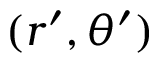<formula> <loc_0><loc_0><loc_500><loc_500>( r ^ { \prime } , \theta ^ { \prime } )</formula> 